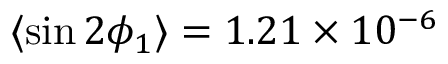<formula> <loc_0><loc_0><loc_500><loc_500>\langle \sin 2 \phi _ { 1 } \rangle = 1 . 2 1 \times 1 0 ^ { - 6 }</formula> 